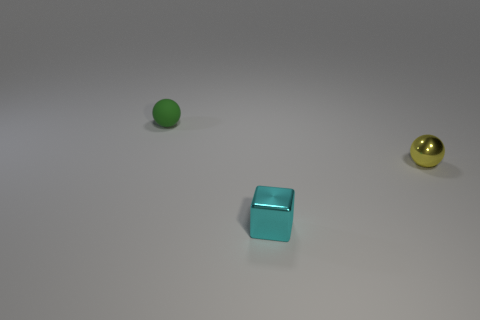There is a ball in front of the tiny matte sphere; what is it made of?
Your response must be concise. Metal. There is a metal cube that is the same size as the shiny ball; what is its color?
Ensure brevity in your answer.  Cyan. Are there the same number of cyan things left of the tiny cyan object and small green balls on the left side of the small yellow ball?
Provide a short and direct response. No. What size is the shiny thing that is behind the cyan cube?
Give a very brief answer. Small. What is the small object that is on the left side of the yellow metal ball and right of the small green sphere made of?
Offer a very short reply. Metal. Does the green sphere have the same material as the tiny yellow sphere?
Ensure brevity in your answer.  No. There is a tiny ball that is behind the sphere that is in front of the tiny sphere that is left of the metal cube; what is its color?
Provide a succinct answer. Green. What number of tiny things are right of the rubber object and behind the small cyan block?
Offer a very short reply. 1. What material is the ball that is in front of the tiny ball that is to the left of the tiny yellow metallic ball made of?
Keep it short and to the point. Metal. There is a cyan object that is the same size as the yellow metallic sphere; what shape is it?
Give a very brief answer. Cube. 